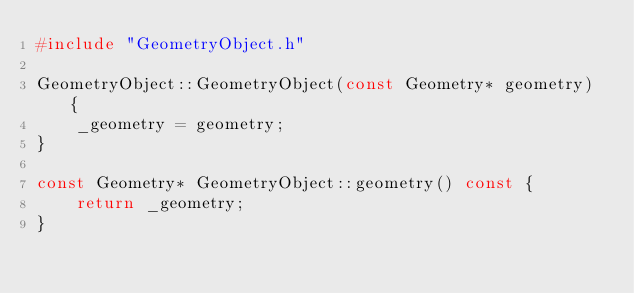Convert code to text. <code><loc_0><loc_0><loc_500><loc_500><_C++_>#include "GeometryObject.h"

GeometryObject::GeometryObject(const Geometry* geometry) {
	_geometry = geometry;
}

const Geometry* GeometryObject::geometry() const {
	return _geometry;
}</code> 